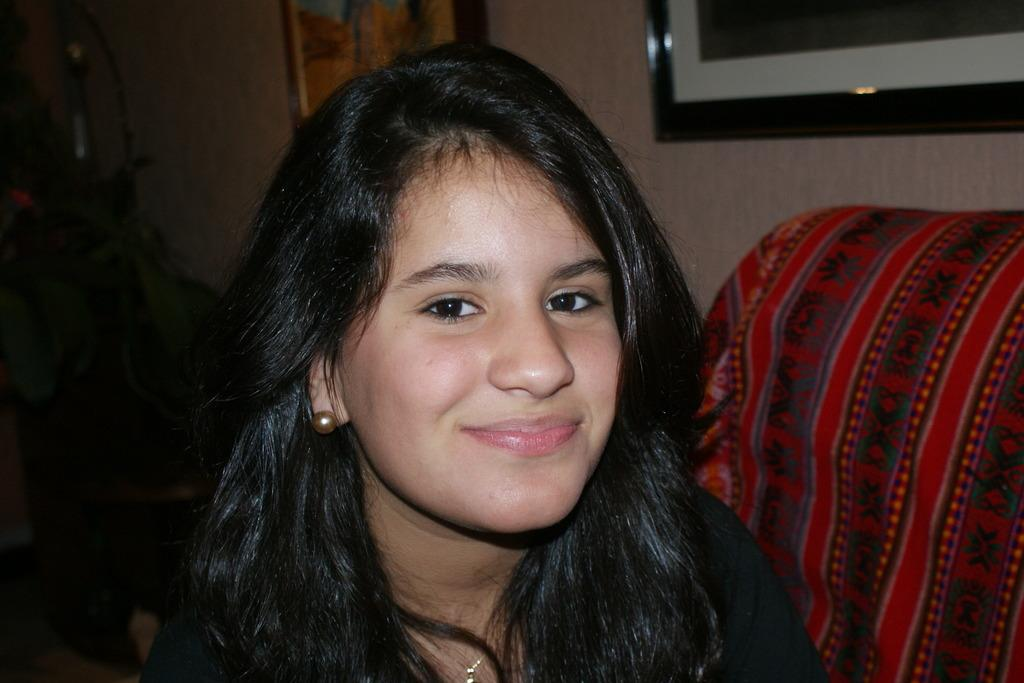Who is present in the image? There is a woman in the image. What can be seen in the background of the image? There is a cloth and photo frames on the wall in the background of the image. What type of fruit is hanging from the twig in the image? There is no fruit or twig present in the image. Is the woman wearing a coat in the image? The provided facts do not mention a coat, so we cannot determine if the woman is wearing one in the image. 